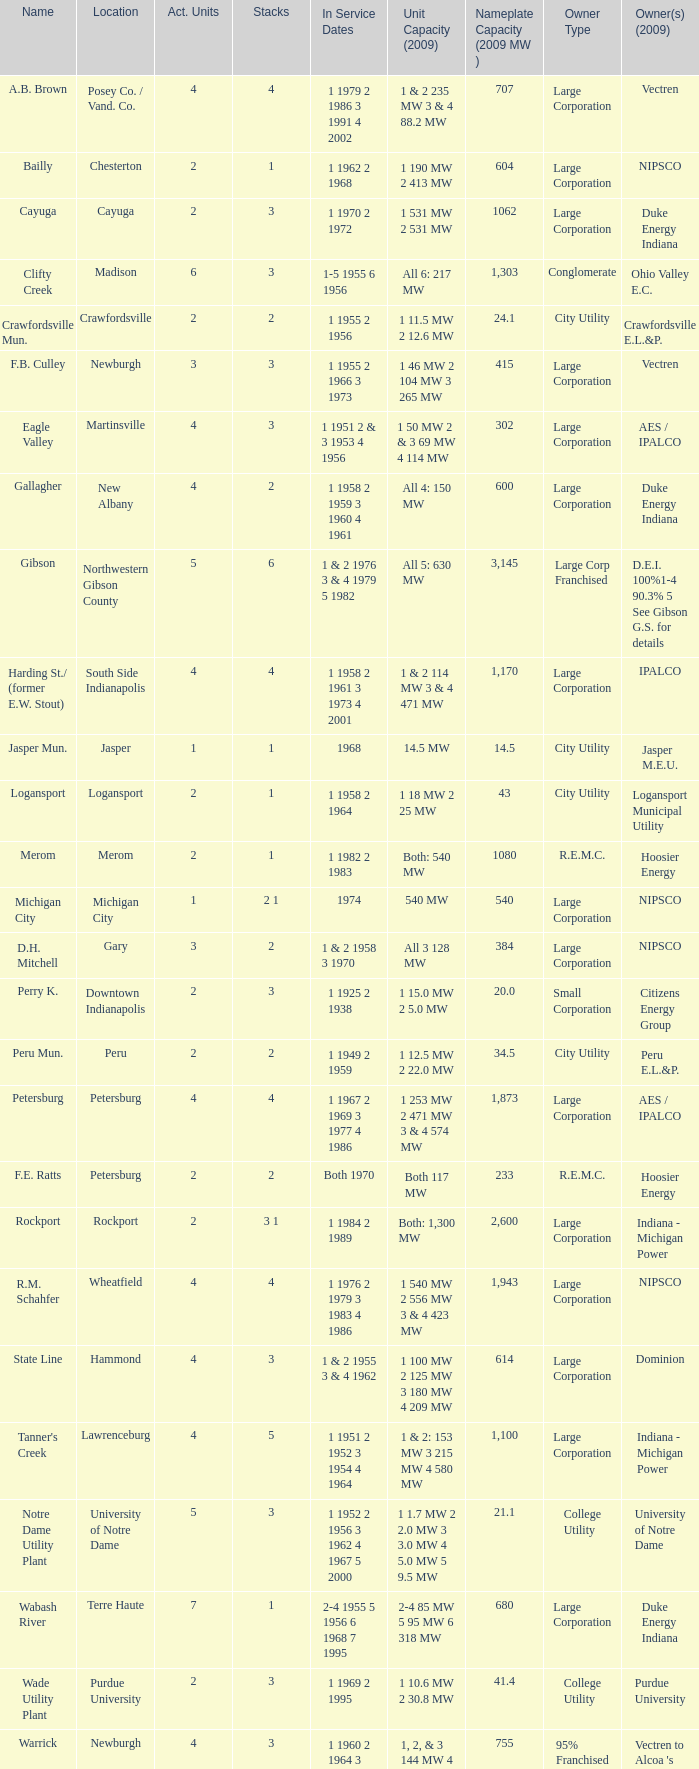Name the number of stacks for 1 & 2 235 mw 3 & 4 88.2 mw 1.0. 